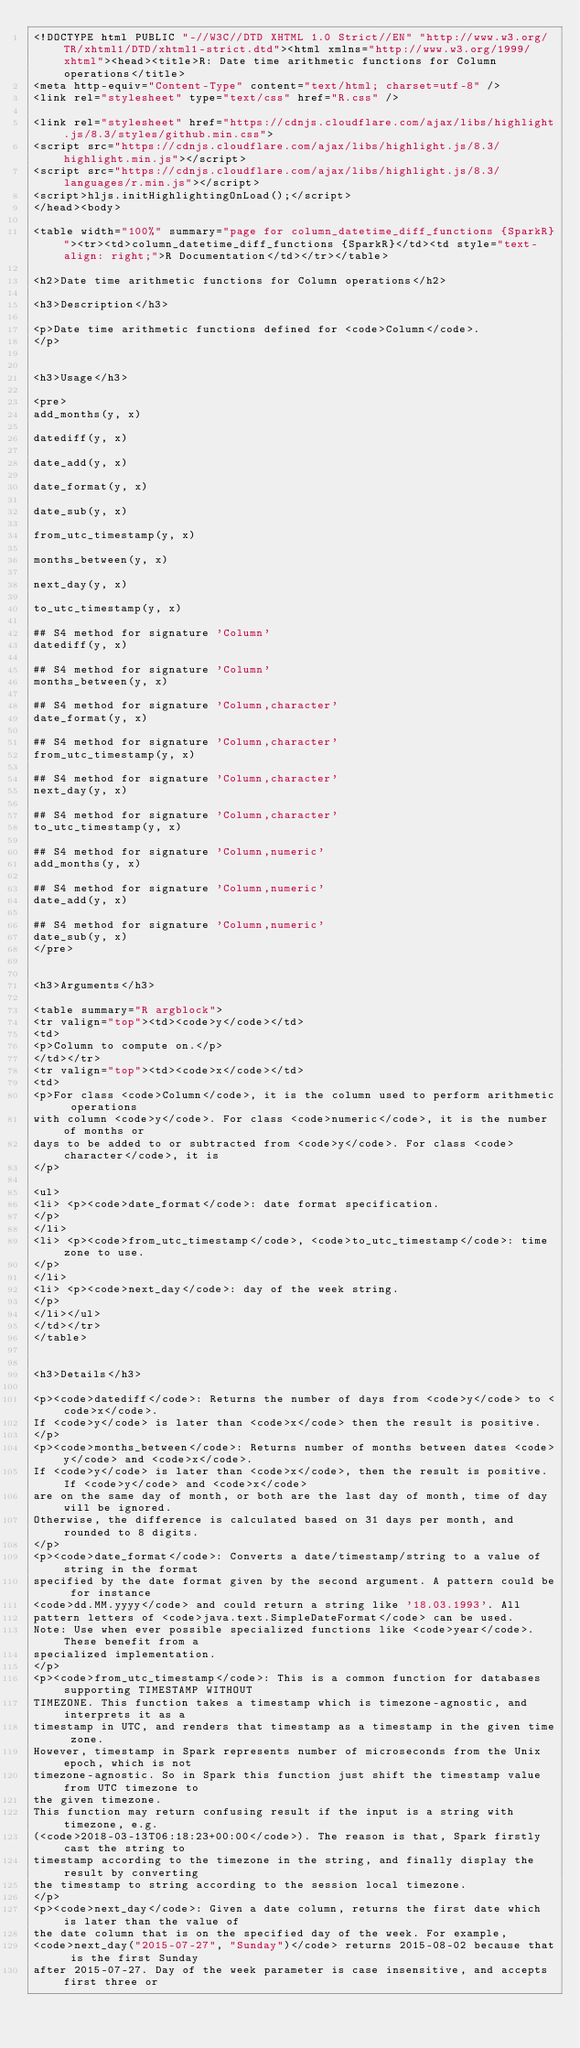Convert code to text. <code><loc_0><loc_0><loc_500><loc_500><_HTML_><!DOCTYPE html PUBLIC "-//W3C//DTD XHTML 1.0 Strict//EN" "http://www.w3.org/TR/xhtml1/DTD/xhtml1-strict.dtd"><html xmlns="http://www.w3.org/1999/xhtml"><head><title>R: Date time arithmetic functions for Column operations</title>
<meta http-equiv="Content-Type" content="text/html; charset=utf-8" />
<link rel="stylesheet" type="text/css" href="R.css" />

<link rel="stylesheet" href="https://cdnjs.cloudflare.com/ajax/libs/highlight.js/8.3/styles/github.min.css">
<script src="https://cdnjs.cloudflare.com/ajax/libs/highlight.js/8.3/highlight.min.js"></script>
<script src="https://cdnjs.cloudflare.com/ajax/libs/highlight.js/8.3/languages/r.min.js"></script>
<script>hljs.initHighlightingOnLoad();</script>
</head><body>

<table width="100%" summary="page for column_datetime_diff_functions {SparkR}"><tr><td>column_datetime_diff_functions {SparkR}</td><td style="text-align: right;">R Documentation</td></tr></table>

<h2>Date time arithmetic functions for Column operations</h2>

<h3>Description</h3>

<p>Date time arithmetic functions defined for <code>Column</code>.
</p>


<h3>Usage</h3>

<pre>
add_months(y, x)

datediff(y, x)

date_add(y, x)

date_format(y, x)

date_sub(y, x)

from_utc_timestamp(y, x)

months_between(y, x)

next_day(y, x)

to_utc_timestamp(y, x)

## S4 method for signature 'Column'
datediff(y, x)

## S4 method for signature 'Column'
months_between(y, x)

## S4 method for signature 'Column,character'
date_format(y, x)

## S4 method for signature 'Column,character'
from_utc_timestamp(y, x)

## S4 method for signature 'Column,character'
next_day(y, x)

## S4 method for signature 'Column,character'
to_utc_timestamp(y, x)

## S4 method for signature 'Column,numeric'
add_months(y, x)

## S4 method for signature 'Column,numeric'
date_add(y, x)

## S4 method for signature 'Column,numeric'
date_sub(y, x)
</pre>


<h3>Arguments</h3>

<table summary="R argblock">
<tr valign="top"><td><code>y</code></td>
<td>
<p>Column to compute on.</p>
</td></tr>
<tr valign="top"><td><code>x</code></td>
<td>
<p>For class <code>Column</code>, it is the column used to perform arithmetic operations
with column <code>y</code>. For class <code>numeric</code>, it is the number of months or
days to be added to or subtracted from <code>y</code>. For class <code>character</code>, it is
</p>

<ul>
<li> <p><code>date_format</code>: date format specification.
</p>
</li>
<li> <p><code>from_utc_timestamp</code>, <code>to_utc_timestamp</code>: time zone to use.
</p>
</li>
<li> <p><code>next_day</code>: day of the week string.
</p>
</li></ul>
</td></tr>
</table>


<h3>Details</h3>

<p><code>datediff</code>: Returns the number of days from <code>y</code> to <code>x</code>.
If <code>y</code> is later than <code>x</code> then the result is positive.
</p>
<p><code>months_between</code>: Returns number of months between dates <code>y</code> and <code>x</code>.
If <code>y</code> is later than <code>x</code>, then the result is positive. If <code>y</code> and <code>x</code>
are on the same day of month, or both are the last day of month, time of day will be ignored.
Otherwise, the difference is calculated based on 31 days per month, and rounded to 8 digits.
</p>
<p><code>date_format</code>: Converts a date/timestamp/string to a value of string in the format
specified by the date format given by the second argument. A pattern could be for instance
<code>dd.MM.yyyy</code> and could return a string like '18.03.1993'. All
pattern letters of <code>java.text.SimpleDateFormat</code> can be used.
Note: Use when ever possible specialized functions like <code>year</code>. These benefit from a
specialized implementation.
</p>
<p><code>from_utc_timestamp</code>: This is a common function for databases supporting TIMESTAMP WITHOUT
TIMEZONE. This function takes a timestamp which is timezone-agnostic, and interprets it as a
timestamp in UTC, and renders that timestamp as a timestamp in the given time zone.
However, timestamp in Spark represents number of microseconds from the Unix epoch, which is not
timezone-agnostic. So in Spark this function just shift the timestamp value from UTC timezone to
the given timezone.
This function may return confusing result if the input is a string with timezone, e.g.
(<code>2018-03-13T06:18:23+00:00</code>). The reason is that, Spark firstly cast the string to
timestamp according to the timezone in the string, and finally display the result by converting
the timestamp to string according to the session local timezone.
</p>
<p><code>next_day</code>: Given a date column, returns the first date which is later than the value of
the date column that is on the specified day of the week. For example,
<code>next_day("2015-07-27", "Sunday")</code> returns 2015-08-02 because that is the first Sunday
after 2015-07-27. Day of the week parameter is case insensitive, and accepts first three or</code> 